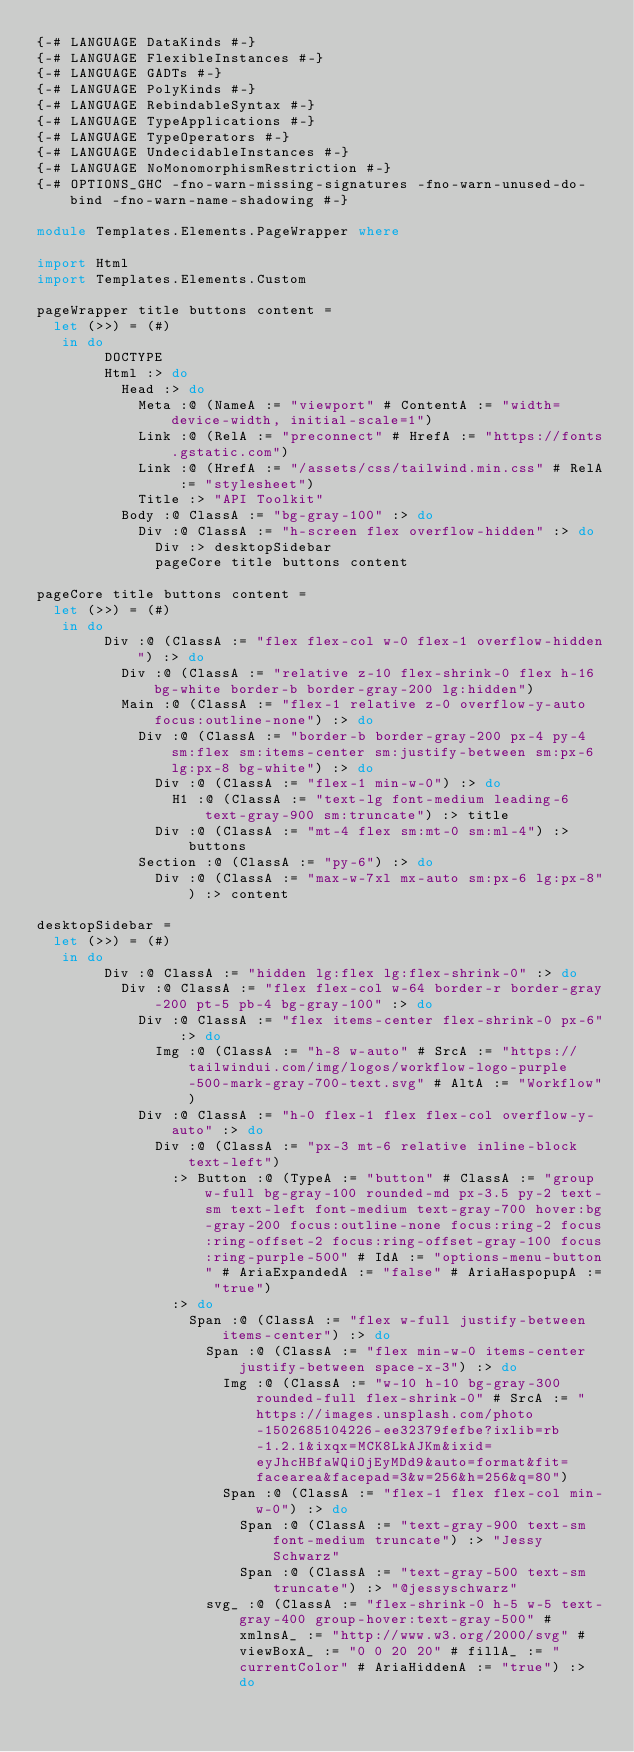<code> <loc_0><loc_0><loc_500><loc_500><_Haskell_>{-# LANGUAGE DataKinds #-}
{-# LANGUAGE FlexibleInstances #-}
{-# LANGUAGE GADTs #-}
{-# LANGUAGE PolyKinds #-}
{-# LANGUAGE RebindableSyntax #-}
{-# LANGUAGE TypeApplications #-}
{-# LANGUAGE TypeOperators #-}
{-# LANGUAGE UndecidableInstances #-}
{-# LANGUAGE NoMonomorphismRestriction #-}
{-# OPTIONS_GHC -fno-warn-missing-signatures -fno-warn-unused-do-bind -fno-warn-name-shadowing #-}

module Templates.Elements.PageWrapper where

import Html
import Templates.Elements.Custom

pageWrapper title buttons content =
  let (>>) = (#)
   in do
        DOCTYPE
        Html :> do
          Head :> do
            Meta :@ (NameA := "viewport" # ContentA := "width=device-width, initial-scale=1")
            Link :@ (RelA := "preconnect" # HrefA := "https://fonts.gstatic.com")
            Link :@ (HrefA := "/assets/css/tailwind.min.css" # RelA := "stylesheet")
            Title :> "API Toolkit"
          Body :@ ClassA := "bg-gray-100" :> do
            Div :@ ClassA := "h-screen flex overflow-hidden" :> do
              Div :> desktopSidebar
              pageCore title buttons content

pageCore title buttons content =
  let (>>) = (#)
   in do
        Div :@ (ClassA := "flex flex-col w-0 flex-1 overflow-hidden") :> do
          Div :@ (ClassA := "relative z-10 flex-shrink-0 flex h-16 bg-white border-b border-gray-200 lg:hidden")
          Main :@ (ClassA := "flex-1 relative z-0 overflow-y-auto focus:outline-none") :> do
            Div :@ (ClassA := "border-b border-gray-200 px-4 py-4 sm:flex sm:items-center sm:justify-between sm:px-6 lg:px-8 bg-white") :> do
              Div :@ (ClassA := "flex-1 min-w-0") :> do
                H1 :@ (ClassA := "text-lg font-medium leading-6 text-gray-900 sm:truncate") :> title
              Div :@ (ClassA := "mt-4 flex sm:mt-0 sm:ml-4") :> buttons
            Section :@ (ClassA := "py-6") :> do
              Div :@ (ClassA := "max-w-7xl mx-auto sm:px-6 lg:px-8") :> content

desktopSidebar =
  let (>>) = (#)
   in do
        Div :@ ClassA := "hidden lg:flex lg:flex-shrink-0" :> do
          Div :@ ClassA := "flex flex-col w-64 border-r border-gray-200 pt-5 pb-4 bg-gray-100" :> do
            Div :@ ClassA := "flex items-center flex-shrink-0 px-6" :> do
              Img :@ (ClassA := "h-8 w-auto" # SrcA := "https://tailwindui.com/img/logos/workflow-logo-purple-500-mark-gray-700-text.svg" # AltA := "Workflow")
            Div :@ ClassA := "h-0 flex-1 flex flex-col overflow-y-auto" :> do
              Div :@ (ClassA := "px-3 mt-6 relative inline-block text-left")
                :> Button :@ (TypeA := "button" # ClassA := "group w-full bg-gray-100 rounded-md px-3.5 py-2 text-sm text-left font-medium text-gray-700 hover:bg-gray-200 focus:outline-none focus:ring-2 focus:ring-offset-2 focus:ring-offset-gray-100 focus:ring-purple-500" # IdA := "options-menu-button" # AriaExpandedA := "false" # AriaHaspopupA := "true")
                :> do
                  Span :@ (ClassA := "flex w-full justify-between items-center") :> do
                    Span :@ (ClassA := "flex min-w-0 items-center justify-between space-x-3") :> do
                      Img :@ (ClassA := "w-10 h-10 bg-gray-300 rounded-full flex-shrink-0" # SrcA := "https://images.unsplash.com/photo-1502685104226-ee32379fefbe?ixlib=rb-1.2.1&ixqx=MCK8LkAJKm&ixid=eyJhcHBfaWQiOjEyMDd9&auto=format&fit=facearea&facepad=3&w=256&h=256&q=80")
                      Span :@ (ClassA := "flex-1 flex flex-col min-w-0") :> do
                        Span :@ (ClassA := "text-gray-900 text-sm font-medium truncate") :> "Jessy Schwarz"
                        Span :@ (ClassA := "text-gray-500 text-sm truncate") :> "@jessyschwarz"
                    svg_ :@ (ClassA := "flex-shrink-0 h-5 w-5 text-gray-400 group-hover:text-gray-500" # xmlnsA_ := "http://www.w3.org/2000/svg" # viewBoxA_ := "0 0 20 20" # fillA_ := "currentColor" # AriaHiddenA := "true") :> do</code> 